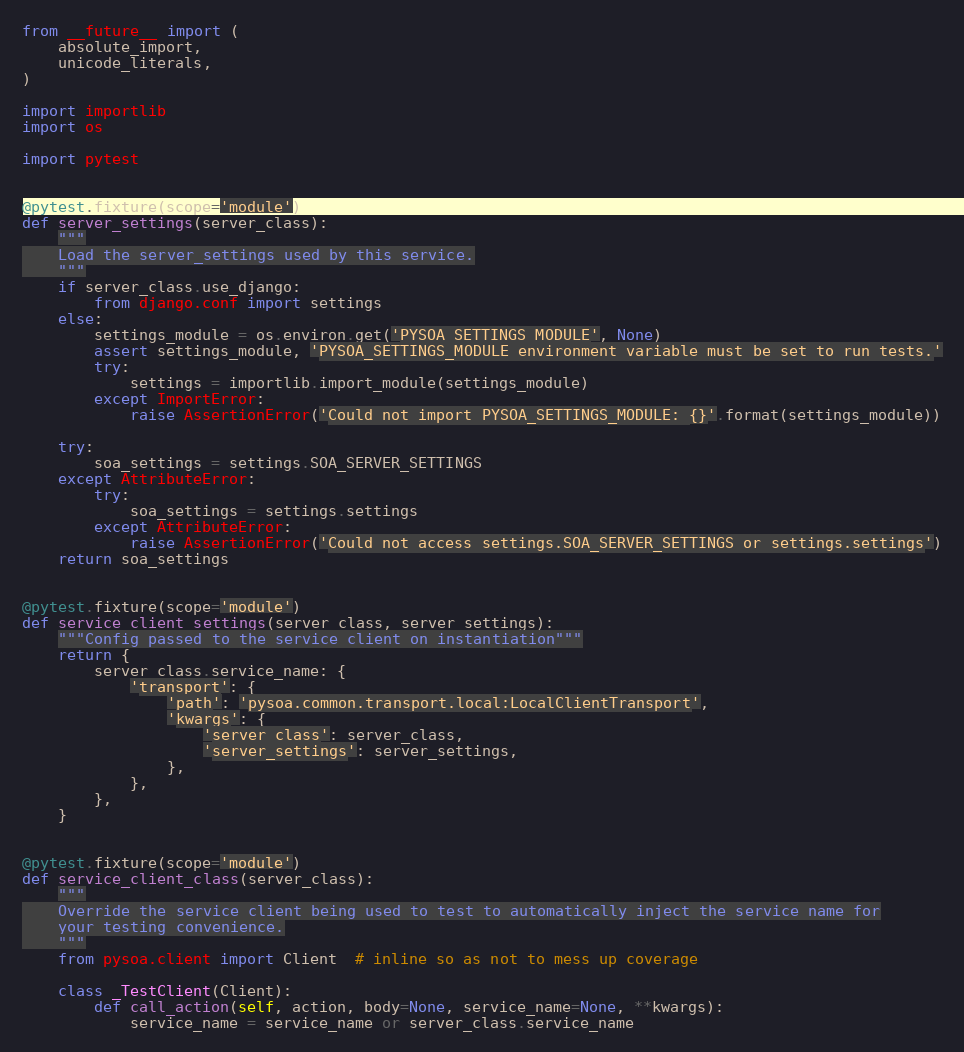Convert code to text. <code><loc_0><loc_0><loc_500><loc_500><_Python_>from __future__ import (
    absolute_import,
    unicode_literals,
)

import importlib
import os

import pytest


@pytest.fixture(scope='module')
def server_settings(server_class):
    """
    Load the server_settings used by this service.
    """
    if server_class.use_django:
        from django.conf import settings
    else:
        settings_module = os.environ.get('PYSOA_SETTINGS_MODULE', None)
        assert settings_module, 'PYSOA_SETTINGS_MODULE environment variable must be set to run tests.'
        try:
            settings = importlib.import_module(settings_module)
        except ImportError:
            raise AssertionError('Could not import PYSOA_SETTINGS_MODULE: {}'.format(settings_module))

    try:
        soa_settings = settings.SOA_SERVER_SETTINGS
    except AttributeError:
        try:
            soa_settings = settings.settings
        except AttributeError:
            raise AssertionError('Could not access settings.SOA_SERVER_SETTINGS or settings.settings')
    return soa_settings


@pytest.fixture(scope='module')
def service_client_settings(server_class, server_settings):
    """Config passed to the service client on instantiation"""
    return {
        server_class.service_name: {
            'transport': {
                'path': 'pysoa.common.transport.local:LocalClientTransport',
                'kwargs': {
                    'server_class': server_class,
                    'server_settings': server_settings,
                },
            },
        },
    }


@pytest.fixture(scope='module')
def service_client_class(server_class):
    """
    Override the service client being used to test to automatically inject the service name for
    your testing convenience.
    """
    from pysoa.client import Client  # inline so as not to mess up coverage

    class _TestClient(Client):
        def call_action(self, action, body=None, service_name=None, **kwargs):
            service_name = service_name or server_class.service_name</code> 